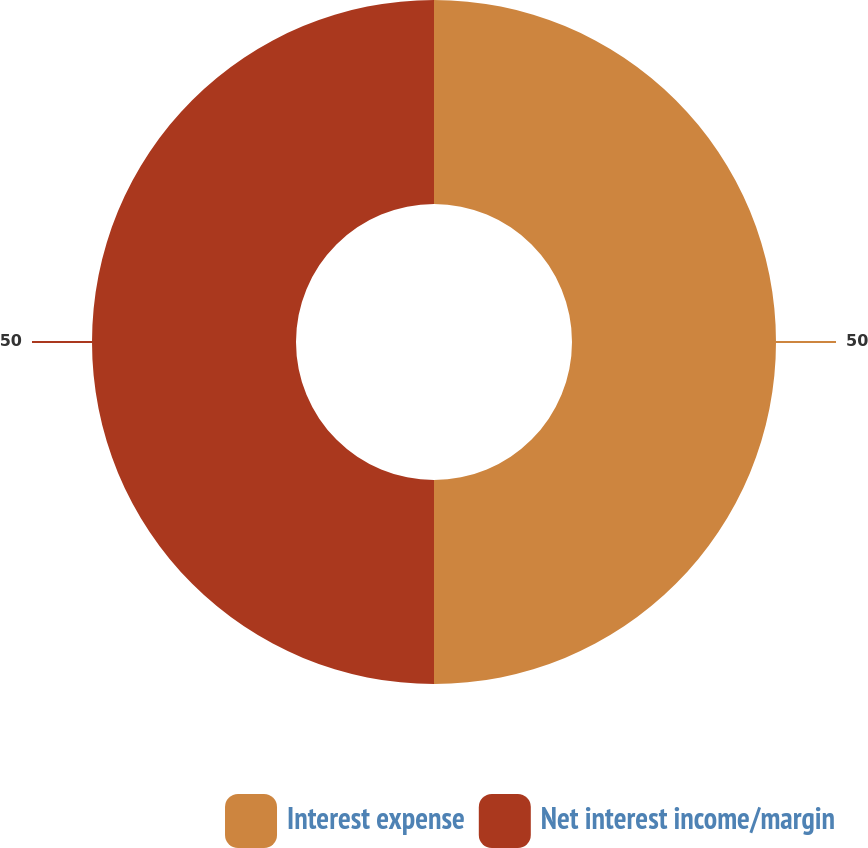Convert chart to OTSL. <chart><loc_0><loc_0><loc_500><loc_500><pie_chart><fcel>Interest expense<fcel>Net interest income/margin<nl><fcel>50.0%<fcel>50.0%<nl></chart> 